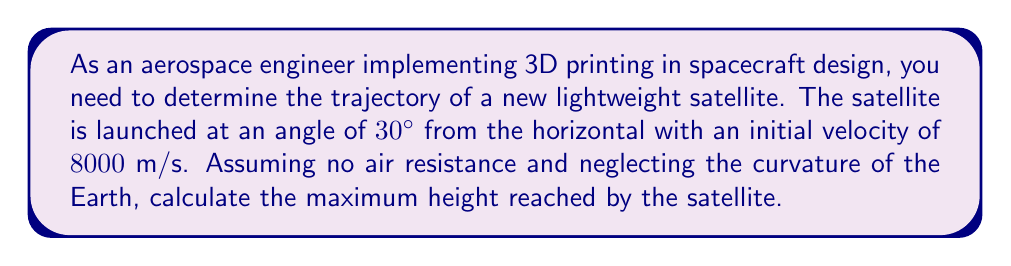What is the answer to this math problem? To solve this problem, we'll use trigonometric functions and the equations of motion for projectile motion. Let's break it down step-by-step:

1) First, we need to determine the vertical component of the initial velocity:
   $v_{y0} = v_0 \sin \theta = 8000 \sin 30^\circ = 4000$ m/s

2) The maximum height is reached when the vertical velocity becomes zero. We can use the equation:
   $v_y^2 = v_{y0}^2 - 2gh_{max}$
   Where $g$ is the acceleration due to gravity (approximately $9.8$ m/s²)

3) At the highest point, $v_y = 0$, so:
   $0 = (4000)^2 - 2(9.8)h_{max}$

4) Solving for $h_{max}$:
   $2(9.8)h_{max} = (4000)^2$
   $h_{max} = \frac{(4000)^2}{2(9.8)} = \frac{16,000,000}{19.6}$

5) Calculating the final result:
   $h_{max} = 816,326.53$ m

[asy]
import geometry;

size(200);
pair O=(0,0), A=(10,0), B=(10,5.77);
draw(O--A--B--O);
label("30°", O, SW);
draw(arc(O,0.75,0,30), Arrow);
label("8000 m/s", (5,1.5), N);
draw((0,0)--(12,0), Arrow);
draw((0,0)--(0,7), Arrow);
label("x", (12,0), E);
label("y", (0,7), N);
label("$h_{max}$", (5,6), E);
[/asy]
Answer: The maximum height reached by the satellite is approximately $816,327$ meters or $816.33$ km. 